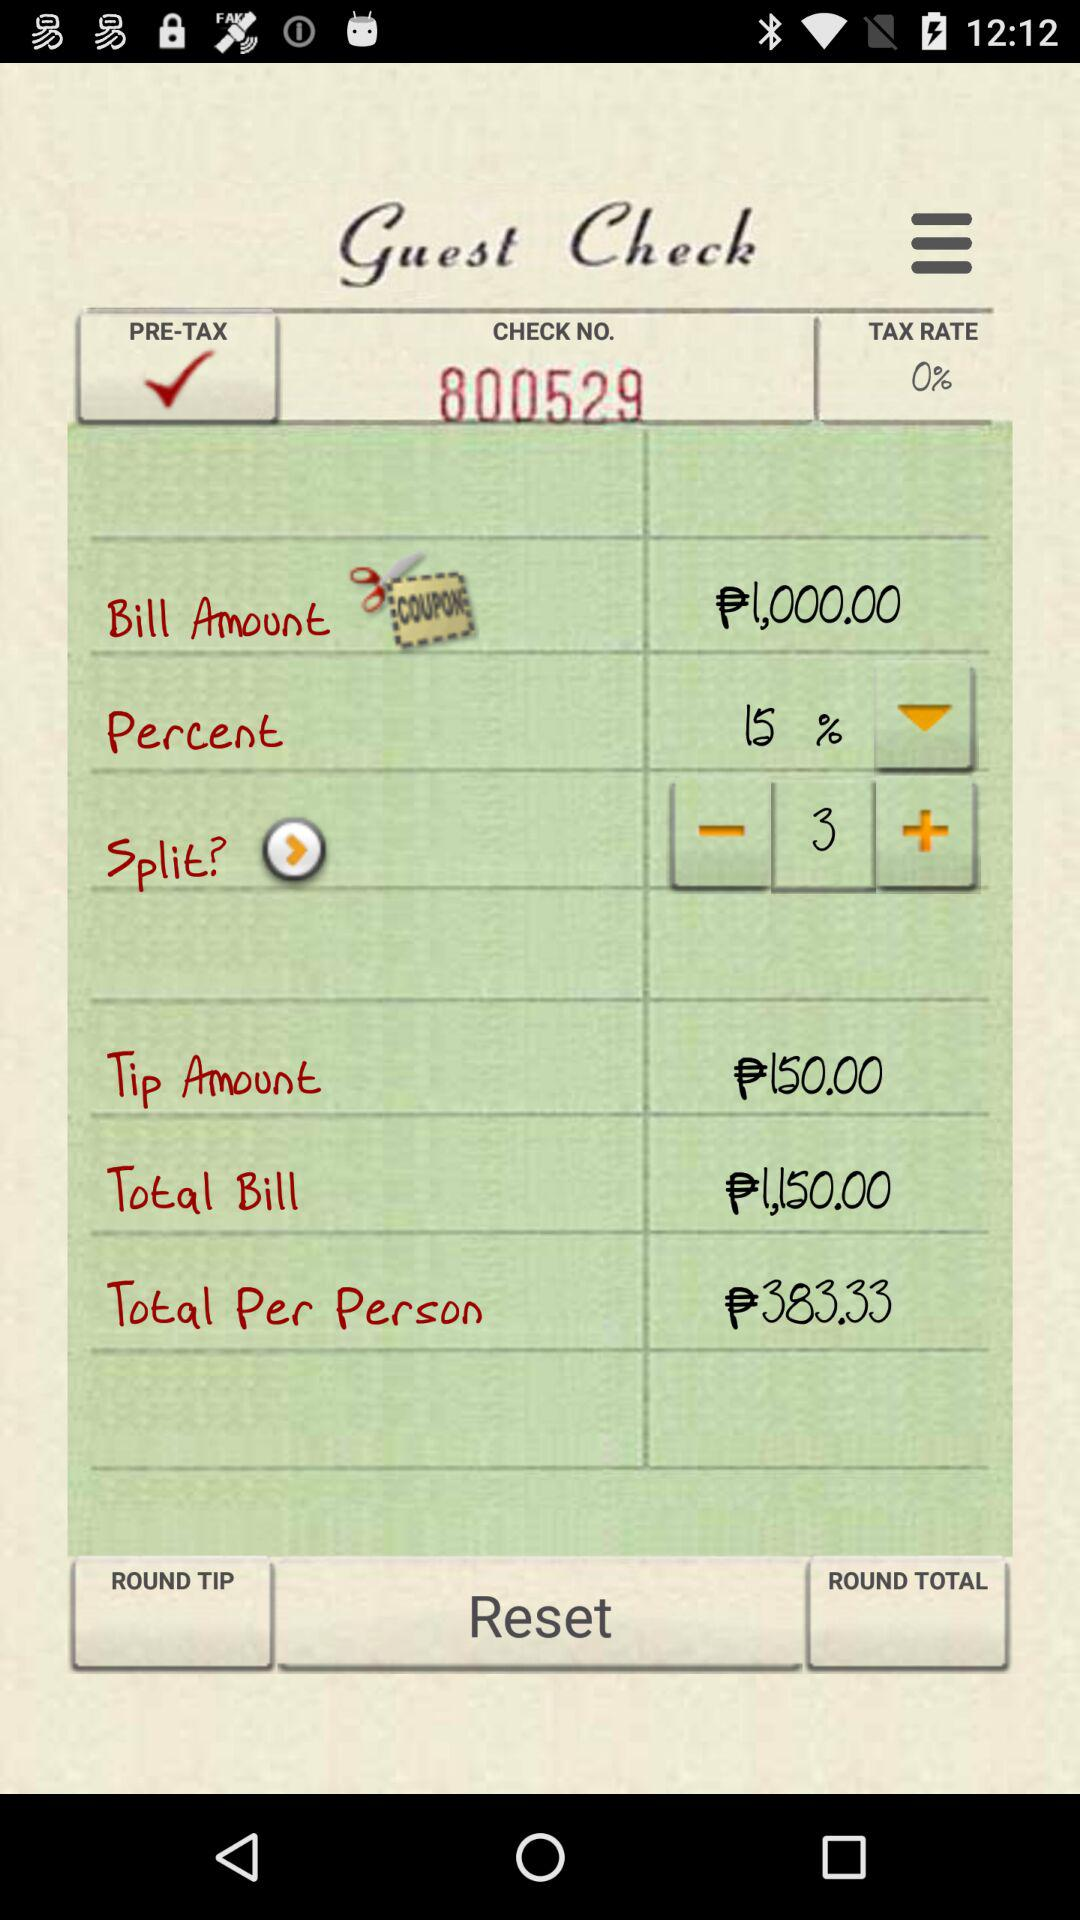How many people will be splitting the bill?
Answer the question using a single word or phrase. 3 